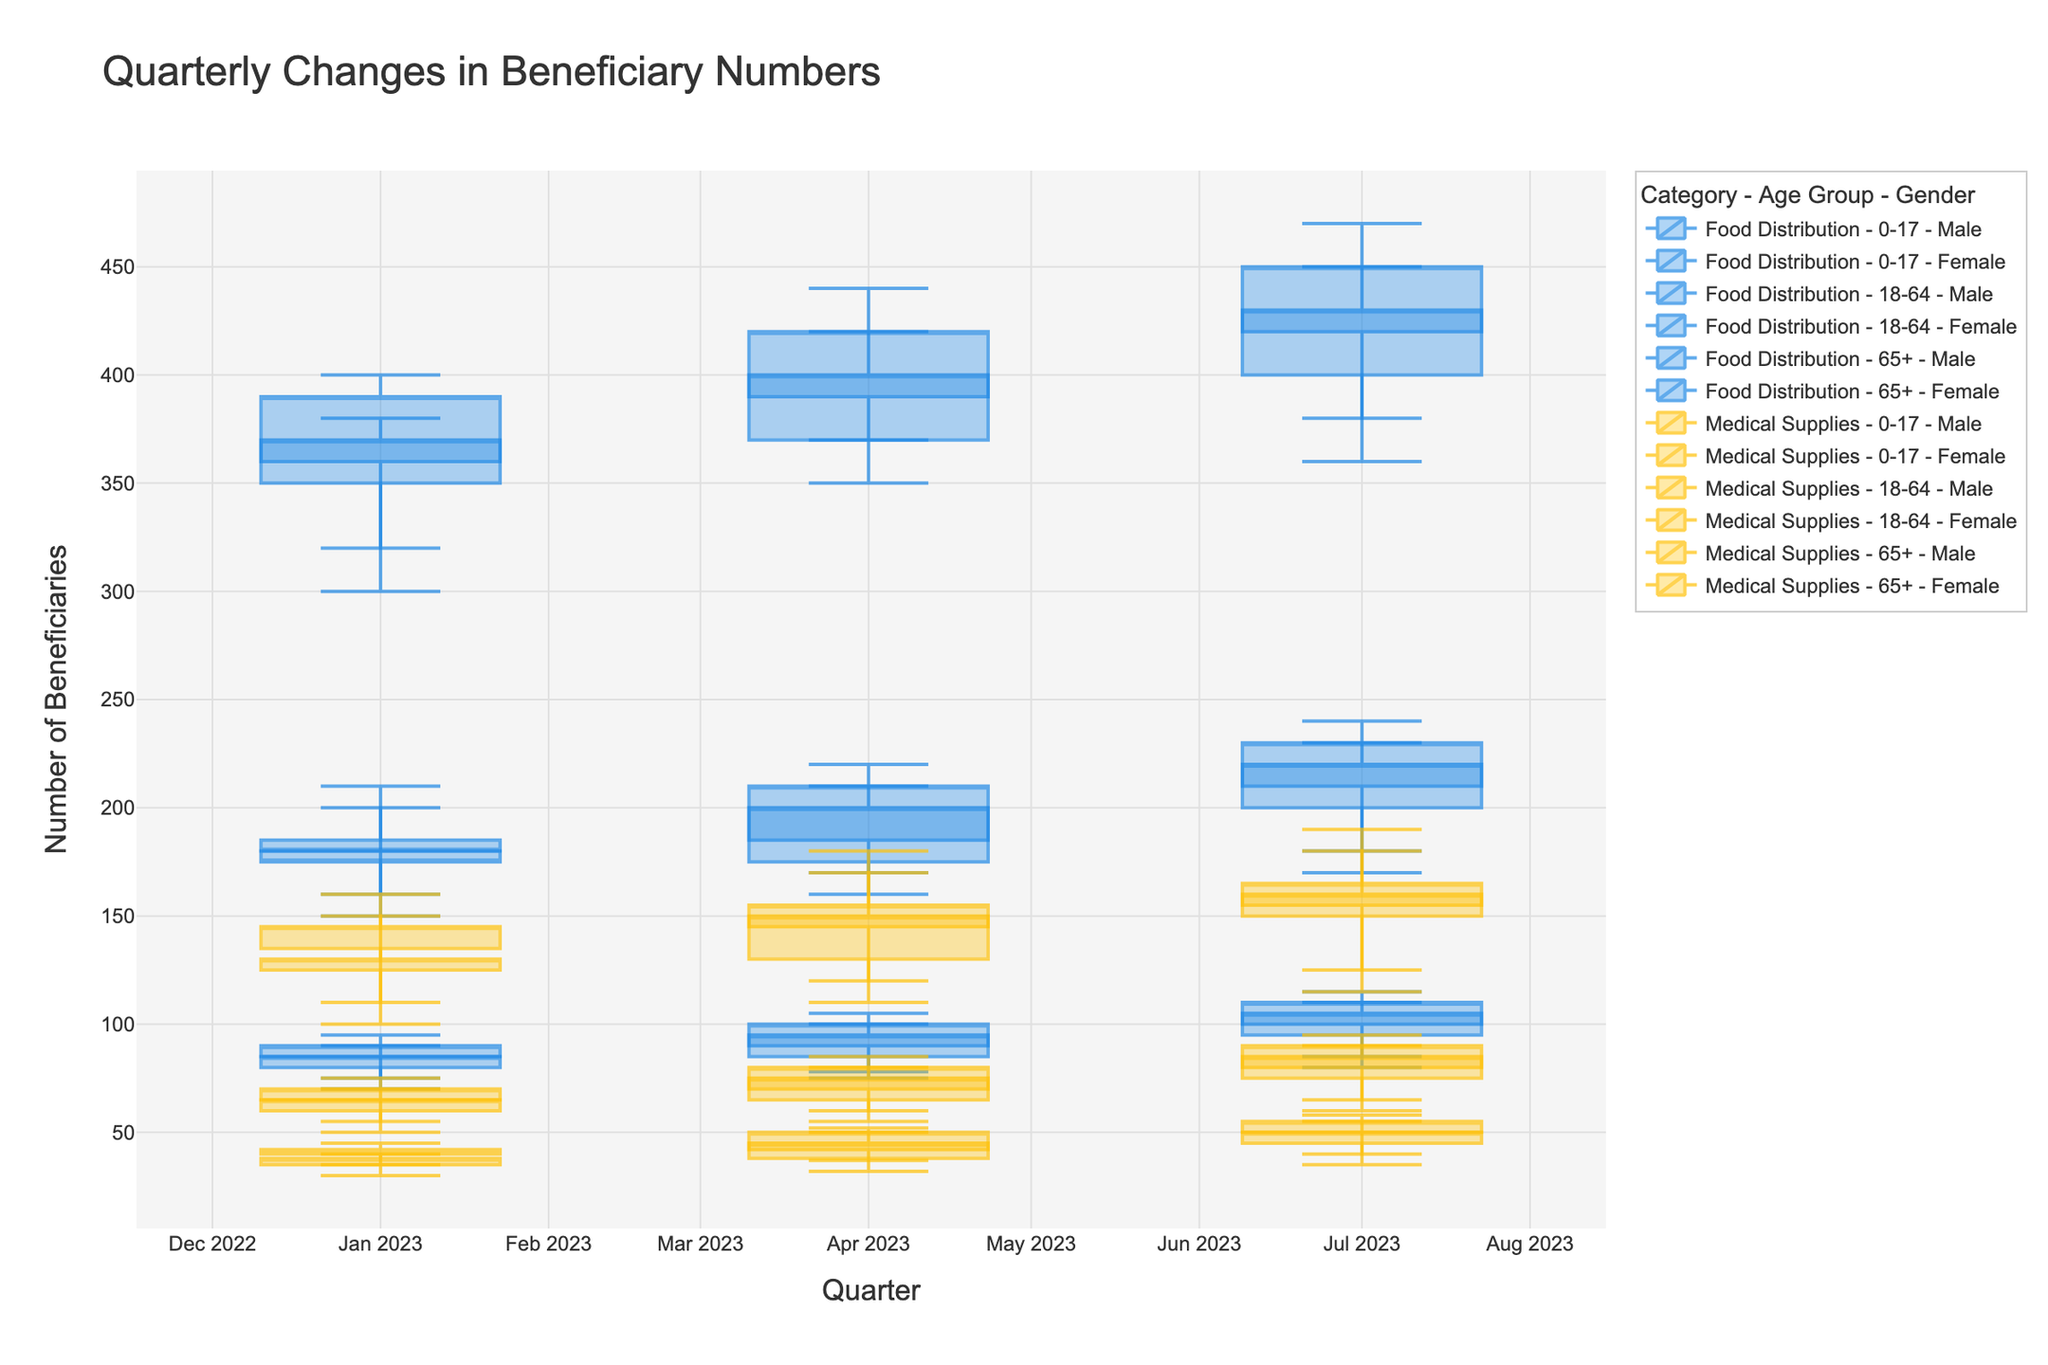How does the number of male beneficiaries aged 18-64 for Food Distribution change from Q1 to Q3? For Q1, the close value is 370, for Q2 it is 400, and for Q3 it is 430. The number increases each quarter.
Answer: Increased each quarter What is the title of the plot? The title of the plot is present at the top and reads "Quarterly Changes in Beneficiary Numbers".
Answer: Quarterly Changes in Beneficiary Numbers Which gender and age group have the highest number of beneficiaries in Q3 for Food Distribution? For Q3 Food Distribution, comparing both gender and all age groups, Female aged 18-64 has the highest close value of 450.
Answer: Female, 18-64 What is the color of the candlestick plots for Medical Supplies? The color used for Medical Supplies candlestick plots is yellow.
Answer: Yellow For Medical Supplies, what is the range of beneficiaries for aged 65+ females in Q2? For males aged 65+ in Medical Supplies Q2, the minimum value is 32 and the maximum value is 50, so the range is 50 - 32 = 18.
Answer: 18 How does the number of female beneficiaries aged 0-17 in Food Distribution during Q2 compare to Q3? In Q2, the close value is 210, and in Q3, it is 230. The number increases by 230 - 210 = 20 beneficiaries.
Answer: Increased by 20 What is the overall trend for the number of male beneficiaries aged 65+ in Medical Supplies across all quarters? From Q1 to Q3, the close values are 38 (Q1), 45 (Q2), and 50 (Q3), indicating a steady increase across all quarters.
Answer: Increasing trend Calculate the average number of female beneficiaries aged 18-64 in Medical Supplies over Q1 to Q3. The close values are 145 (Q1), 155 (Q2), and 165 (Q3). The average is (145 + 155 + 165) / 3 = 155.
Answer: 155 Which quarter had the highest close value for male beneficiaries aged 0-17 for Medical Supplies? Comparing Q1, Q2, and Q3, the close values for males aged 0-17 are 65, 75, and 85 respectively. Q3 has the highest close value.
Answer: Q3 Which category and age group see a decrease in the number of beneficiaries from Q1 to Q2? All provided age groups and categories see an increase when comparing the closing values of Q1 to Q2. Thus, there is no decrease.
Answer: None 